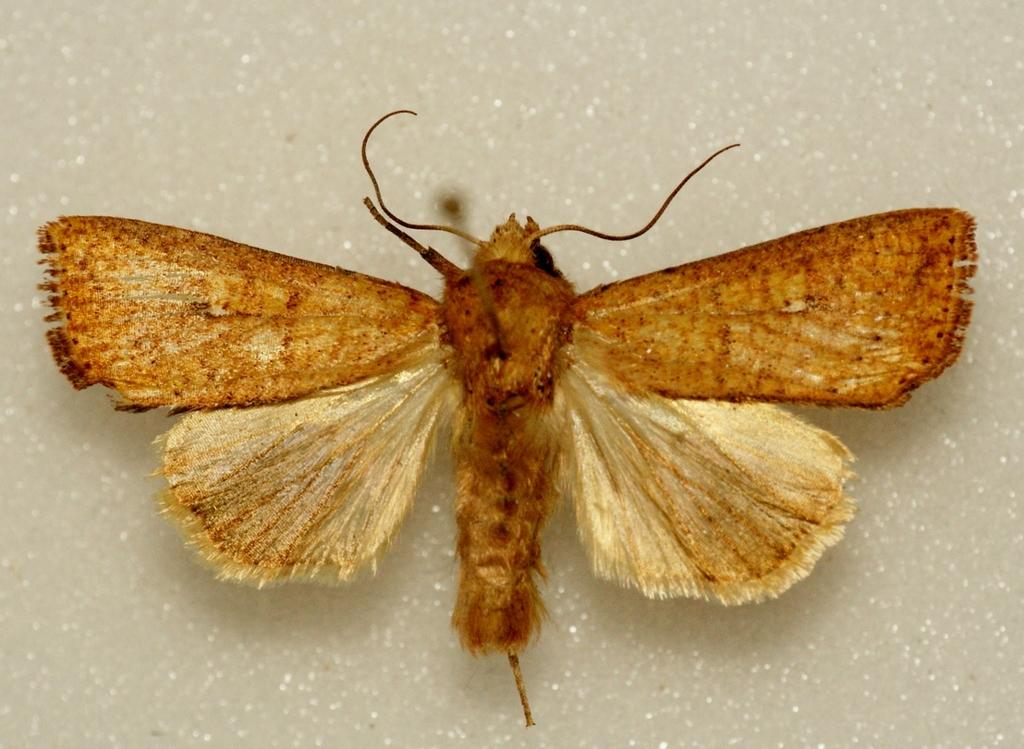What is the main subject of the image? The main subject of the image is a butterfly. Where is the butterfly located in the image? The butterfly is on a surface in the image. What type of sand can be seen in the image? There is no sand present in the image; it features a butterfly on a surface. What type of army is depicted in the image? There is no army present in the image; it features a butterfly on a surface. 